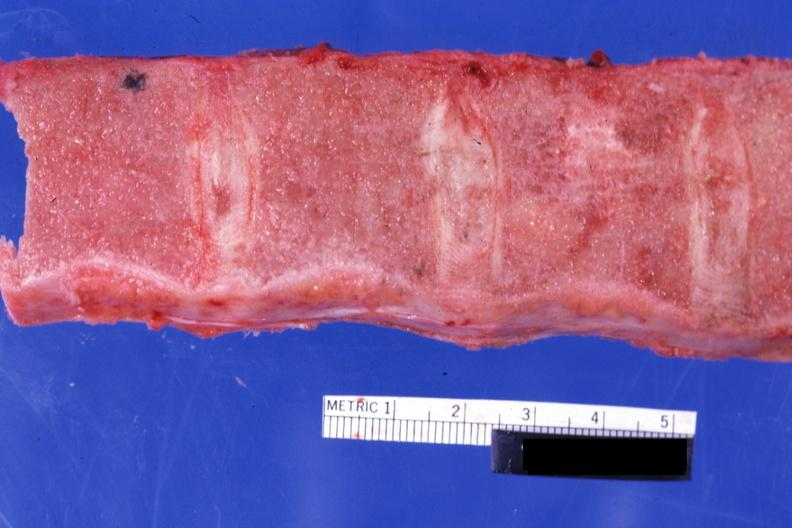does this image show sectioned vertebrae with no red marrow case of chronic myelogenous leukemia in blast crisis?
Answer the question using a single word or phrase. Yes 